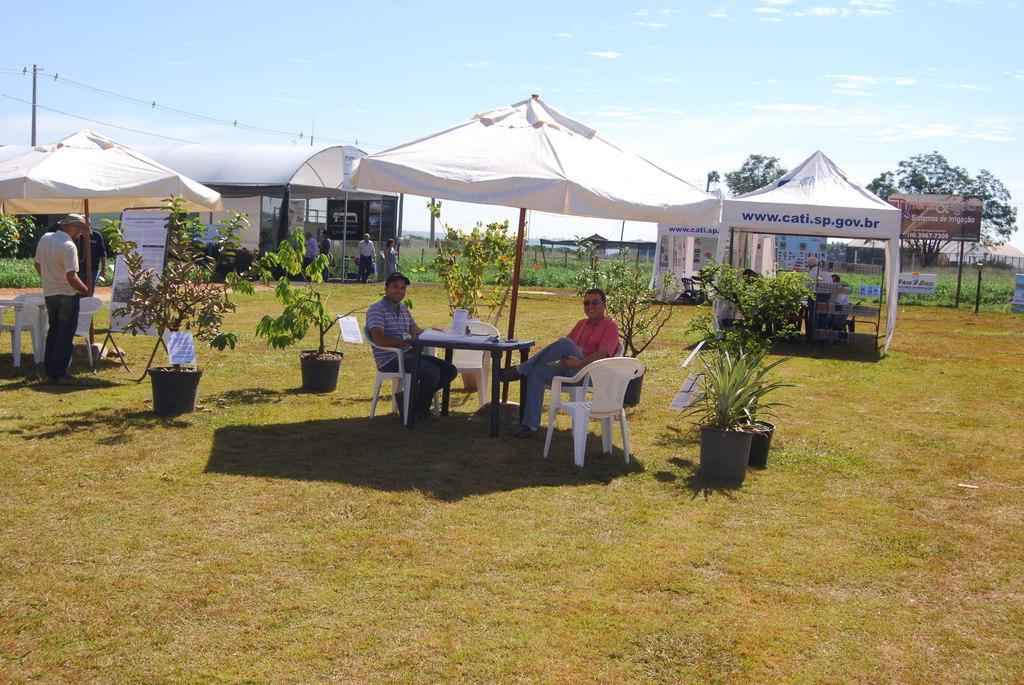Describe this image in one or two sentences. The picture is taken outside the city maybe in a field. In the foreground of the picture there is dry grass. In the center of the picture there are canopies, plants, chairs, people, tables, banner, board, building, current pole, cables, plants, trees and other objects. In the background it is sky, sky is sunny. 